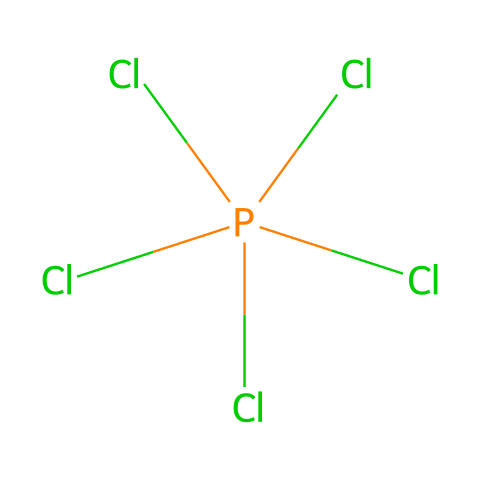What is the chemical name of the compound represented? The SMILES notation indicates the presence of phosphorus and chlorine atoms, specifically in the structure Cl[P](Cl)(Cl)(Cl)Cl, which corresponds to phosphorus pentachloride.
Answer: phosphorus pentachloride How many chlorine atoms are bonded to phosphorus in this structure? The SMILES notation shows four chlorine atoms attached directly to the phosphorus atom. Each 'Cl' before the brackets represents a chlorine atom bonded to phosphorus.
Answer: five What type of chemical compound is phosphorus pentachloride? Phosphorus pentachloride is classified as a hypervalent compound because it has more than four bonds around the phosphorus atom, which allows it to accommodate more than eight electrons in its valence shell.
Answer: hypervalent What historical practice involved the use of phosphorus pentachloride? Phosphorus pentachloride was historically used in alchemical practices, where it was believed to be able to transmute substances, aligning with the alchemical pursuit of converting base materials into noble ones.
Answer: alchemy What role does phosphorus play in phosphorus pentachloride's structure? In the structure Cl[P](Cl)(Cl)(Cl)Cl, phosphorus acts as the central atom that is surrounded by five chlorine atoms, characteristic of hypervalent compounds, playing a crucial role in stabilizing the overall structure.
Answer: central atom Why can phosphorus pentachloride be considered a Lewis acid? Phosphorus pentachloride can accept a pair of electrons due to the empty d orbitals in phosphorus, which allows it to act as a Lewis acid in chemical reactions, providing its hypervalent nature as key to this characteristic.
Answer: Lewis acid 